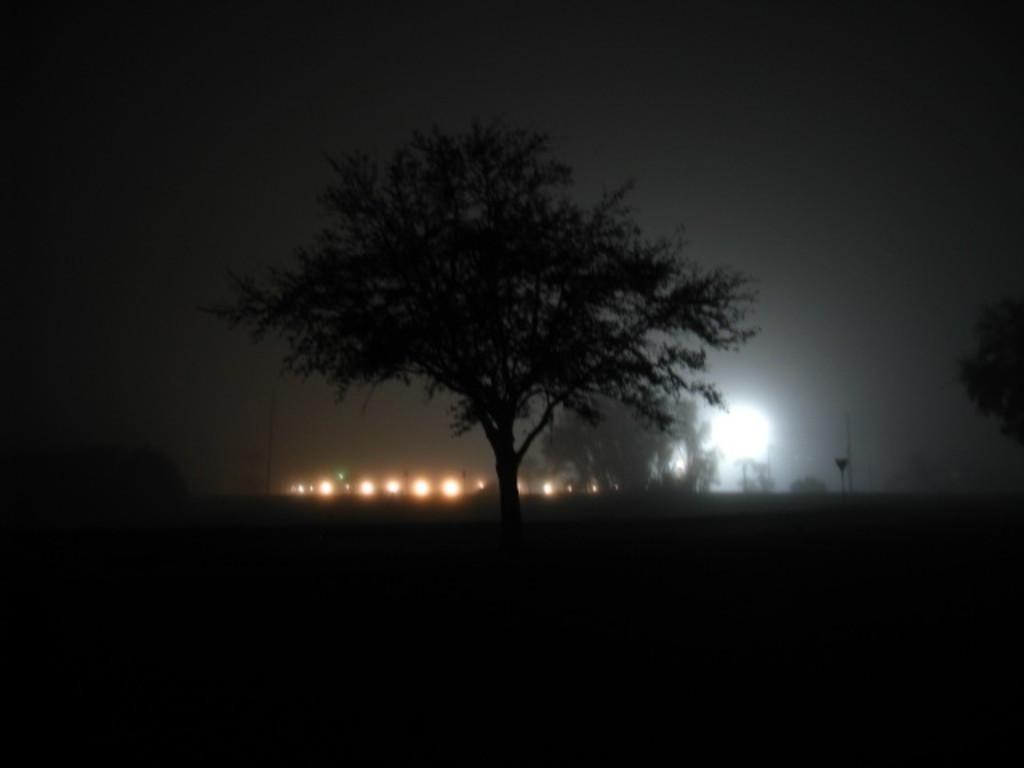What type of vegetation can be seen in the image? There are trees in the image. What can be seen in the background of the image? There are lights visible in the background of the image. What type of kite is being flown on the roof in the image? There is no kite or roof present in the image; it only features trees and lights in the background. 